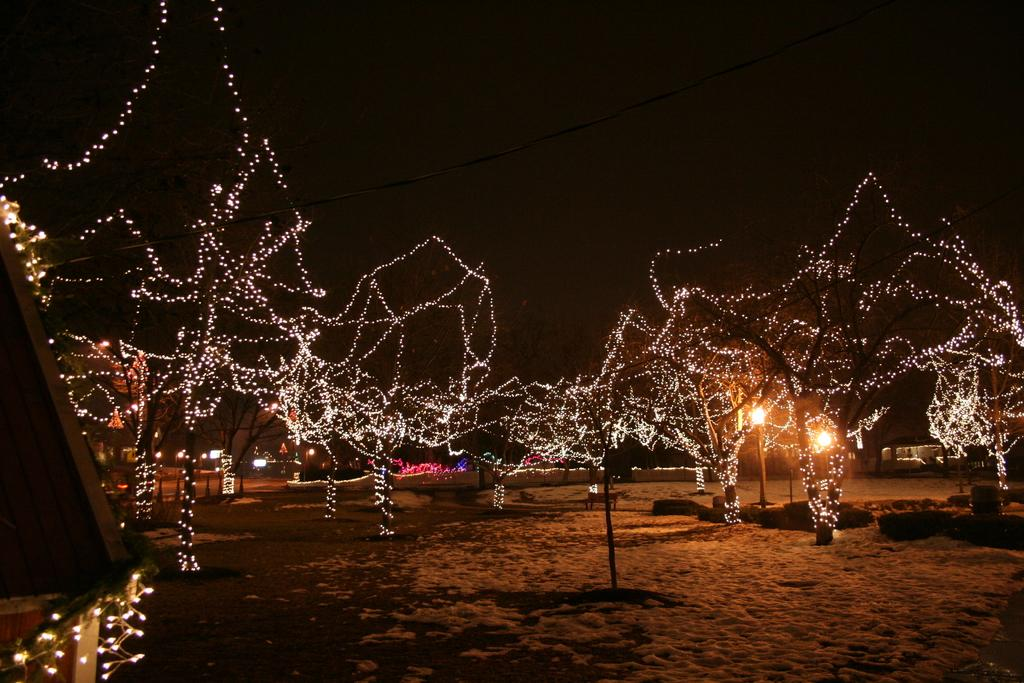What can be seen in the image that provides illumination? There are lights in the image. Where are the lights located? The lights are decorated on trees. What is the color of the background in the image? The background of the image is black, which likely represents the sky. Can you tell me how many sisters are visible in the image? There are no sisters present in the image; it features lights decorated on trees with a black background. 